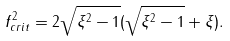<formula> <loc_0><loc_0><loc_500><loc_500>f _ { c r i t } ^ { 2 } = 2 \sqrt { \xi ^ { 2 } - 1 } ( \sqrt { \xi ^ { 2 } - 1 } + \xi ) .</formula> 